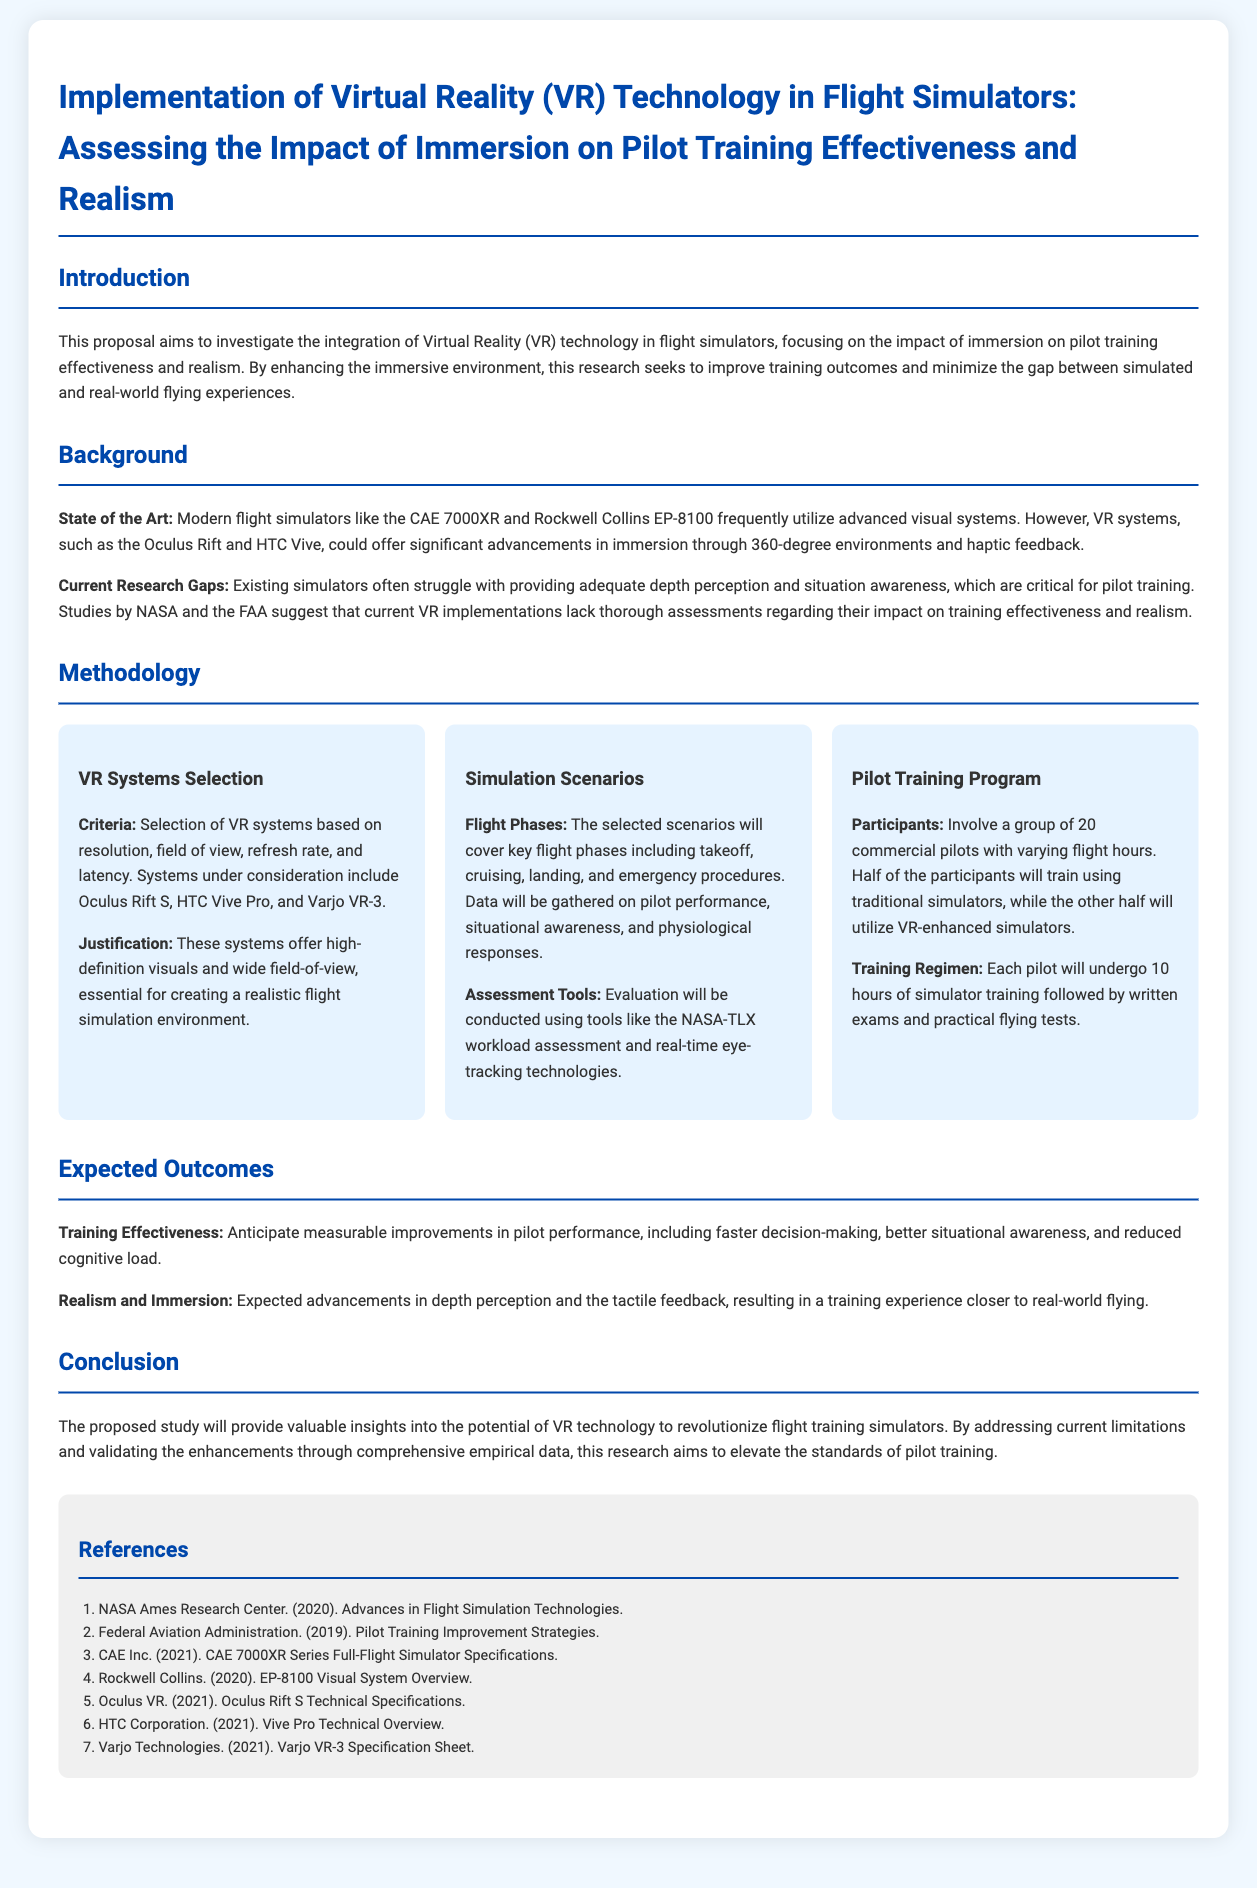What is the title of the proposal? The title is stated at the beginning of the document, summarizing the focus of the research.
Answer: Implementation of Virtual Reality (VR) Technology in Flight Simulators: Assessing the Impact of Immersion on Pilot Training Effectiveness and Realism What VR systems are being considered in the research? The document lists several VR systems under consideration based on defined criteria.
Answer: Oculus Rift S, HTC Vive Pro, and Varjo VR-3 How many commercial pilots will participate in the training program? The number of participants is specified in the methodology section of the proposal.
Answer: 20 What are the key flight phases included in the simulation scenarios? The proposal outlines the flight phases that the scenarios will cover for assessment.
Answer: takeoff, cruising, landing, and emergency procedures What is the expected outcome related to pilot performance? The document discusses improvements expected from implementing VR technology in flight training and highlights specific performance aspects.
Answer: faster decision-making What assessment tools will be used for evaluation? The proposal identifies tools that will gauge pilot performance and workload during training.
Answer: NASA-TLX workload assessment and real-time eye-tracking technologies What is the main objective of the proposed study? The introduction of the document outlines the primary aim of the research.
Answer: Investigate the integration of Virtual Reality (VR) technology in flight simulators Which organization conducted research on flight simulation technologies mentioned in the references? The references include various organizations that have done research relevant to flight simulation.
Answer: NASA Ames Research Center 